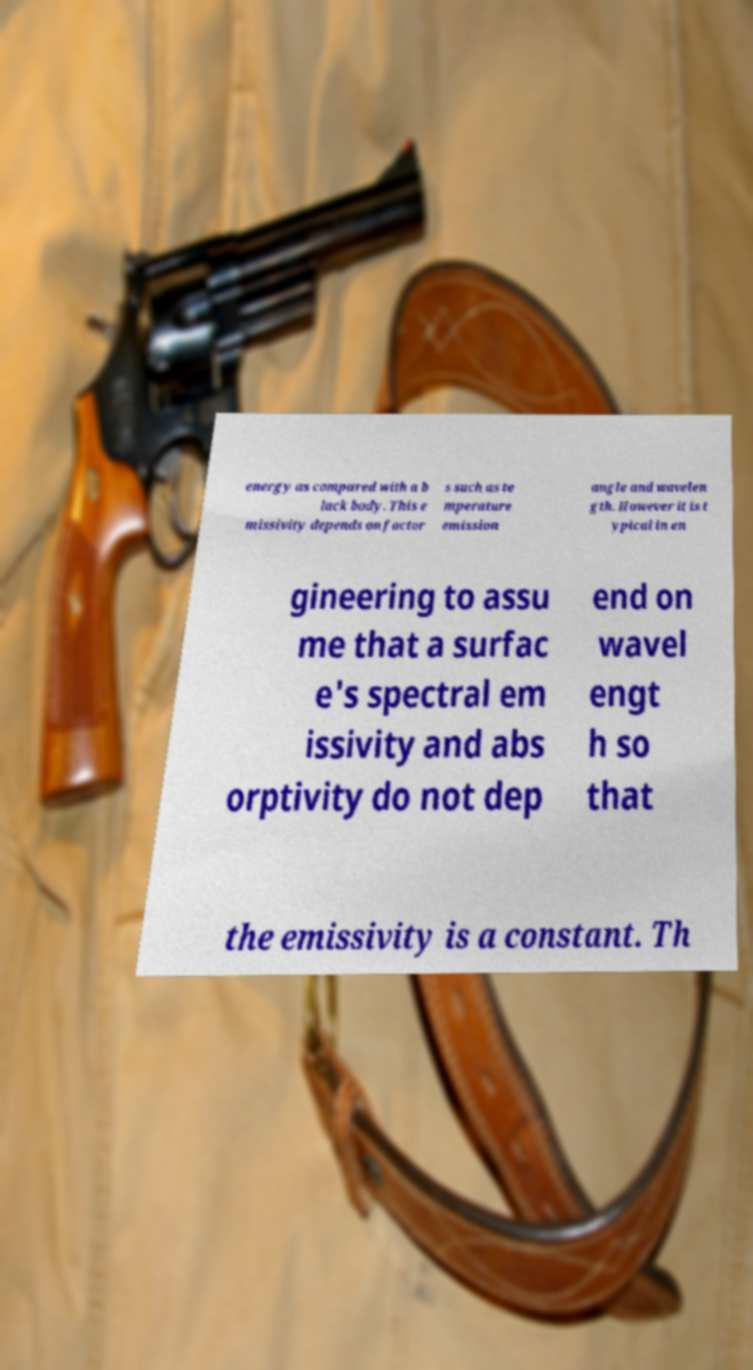For documentation purposes, I need the text within this image transcribed. Could you provide that? energy as compared with a b lack body. This e missivity depends on factor s such as te mperature emission angle and wavelen gth. However it is t ypical in en gineering to assu me that a surfac e's spectral em issivity and abs orptivity do not dep end on wavel engt h so that the emissivity is a constant. Th 